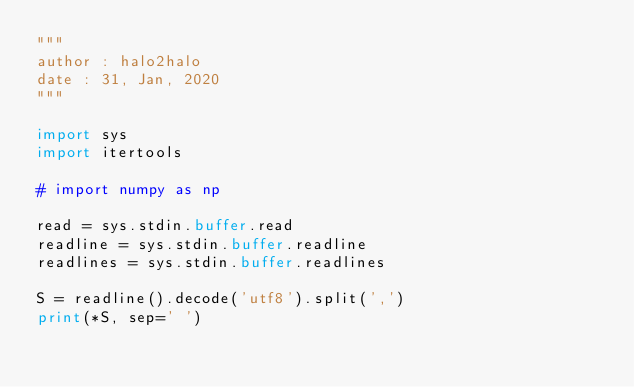Convert code to text. <code><loc_0><loc_0><loc_500><loc_500><_Python_>"""
author : halo2halo
date : 31, Jan, 2020
"""

import sys
import itertools

# import numpy as np

read = sys.stdin.buffer.read
readline = sys.stdin.buffer.readline
readlines = sys.stdin.buffer.readlines

S = readline().decode('utf8').split(',')
print(*S, sep=' ')
</code> 